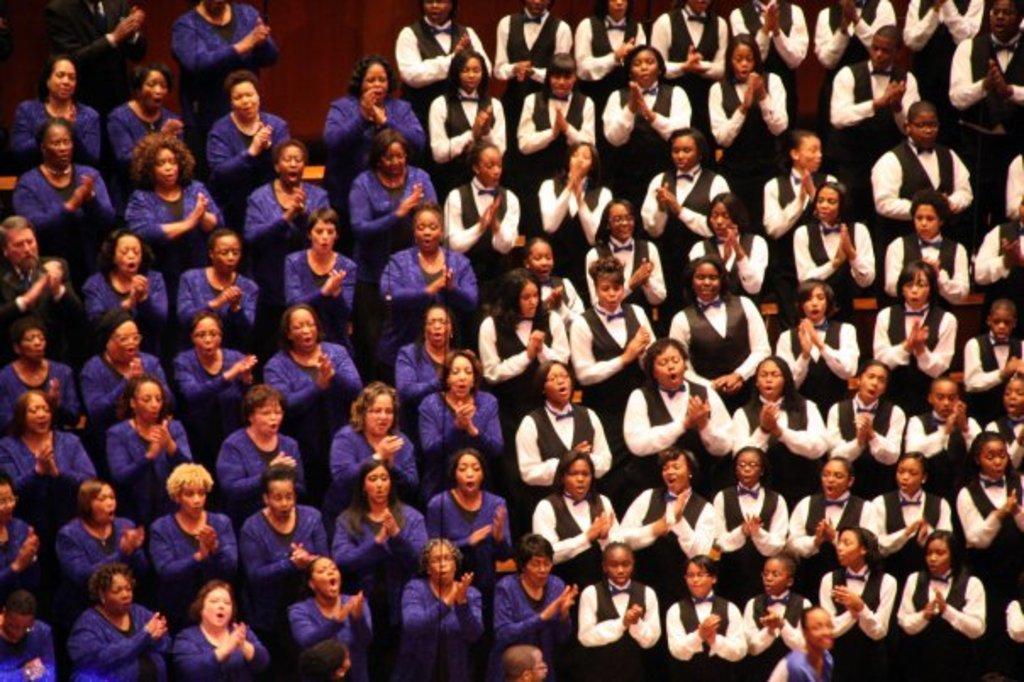Could you give a brief overview of what you see in this image? In the foreground of this image, there is the crowd clapping, half side women are wearing purple color dresses and other half side wearing black and white dresses. 